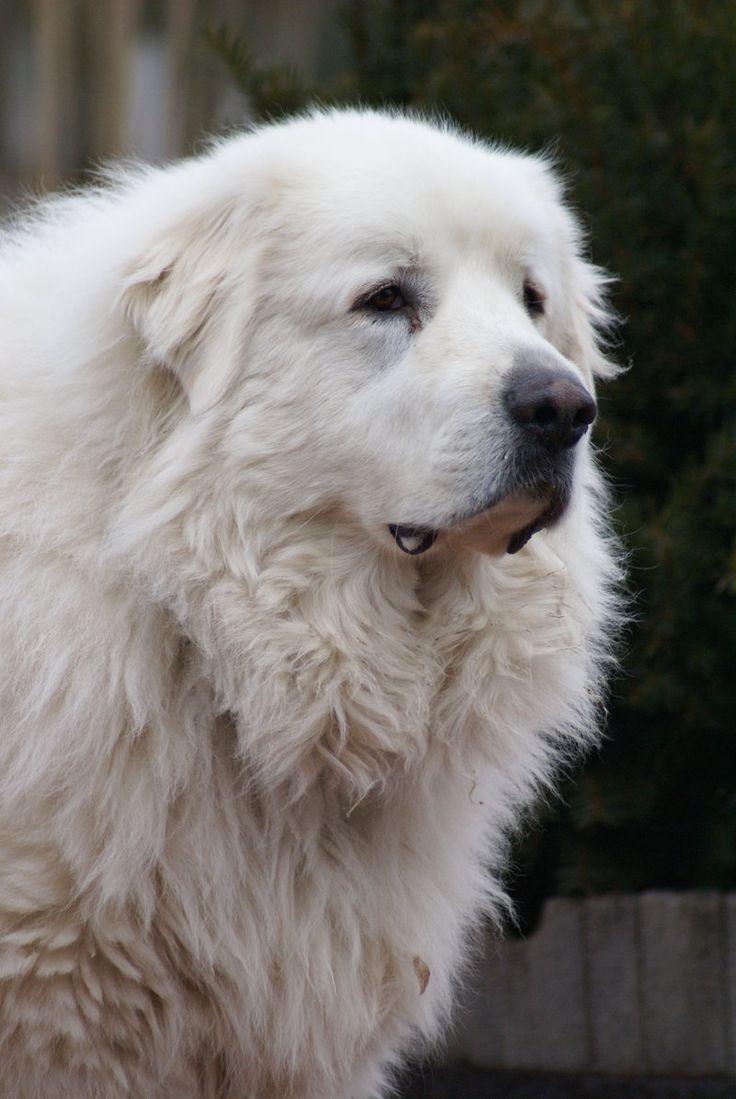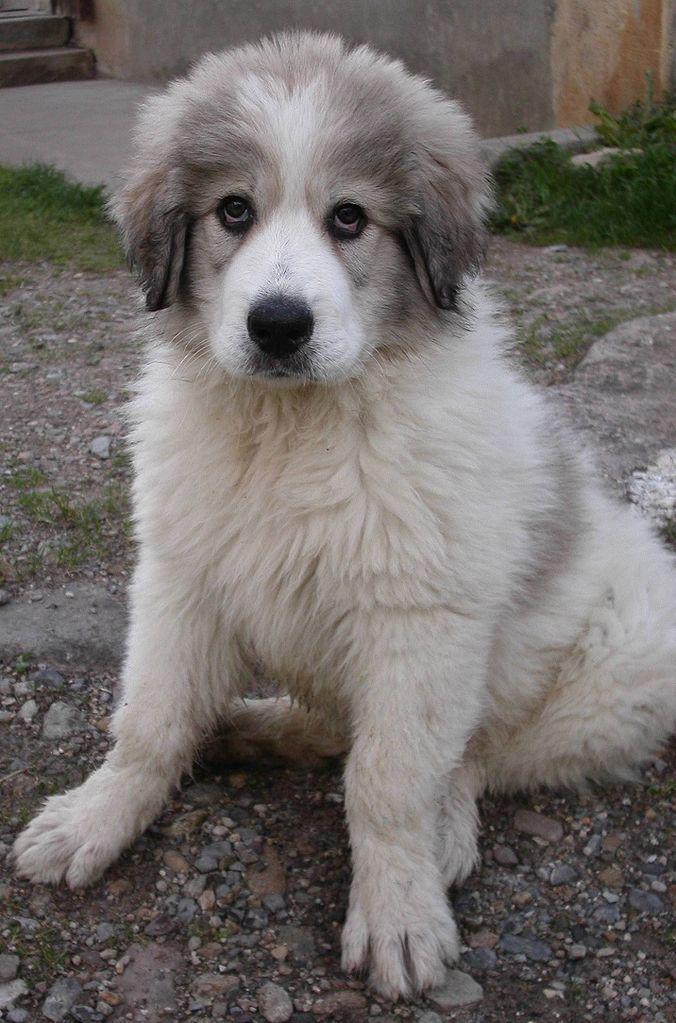The first image is the image on the left, the second image is the image on the right. Analyze the images presented: Is the assertion "There are exactly two dogs." valid? Answer yes or no. Yes. The first image is the image on the left, the second image is the image on the right. Considering the images on both sides, is "there is one dog in the left side pic" valid? Answer yes or no. Yes. 